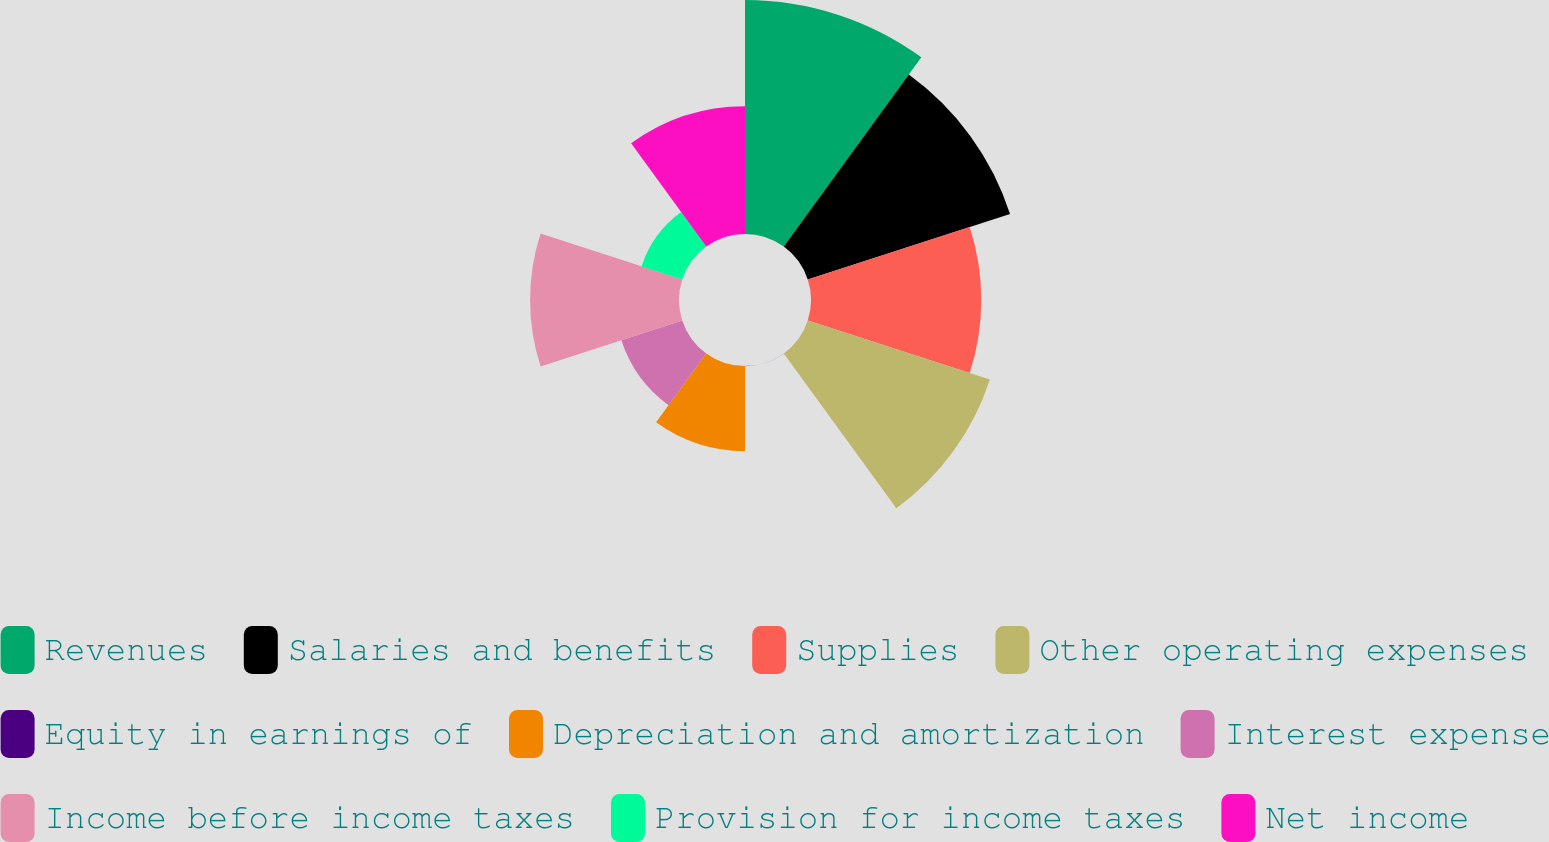Convert chart. <chart><loc_0><loc_0><loc_500><loc_500><pie_chart><fcel>Revenues<fcel>Salaries and benefits<fcel>Supplies<fcel>Other operating expenses<fcel>Equity in earnings of<fcel>Depreciation and amortization<fcel>Interest expense<fcel>Income before income taxes<fcel>Provision for income taxes<fcel>Net income<nl><fcel>18.32%<fcel>16.65%<fcel>13.33%<fcel>14.99%<fcel>0.02%<fcel>6.67%<fcel>5.01%<fcel>11.66%<fcel>3.35%<fcel>10.0%<nl></chart> 